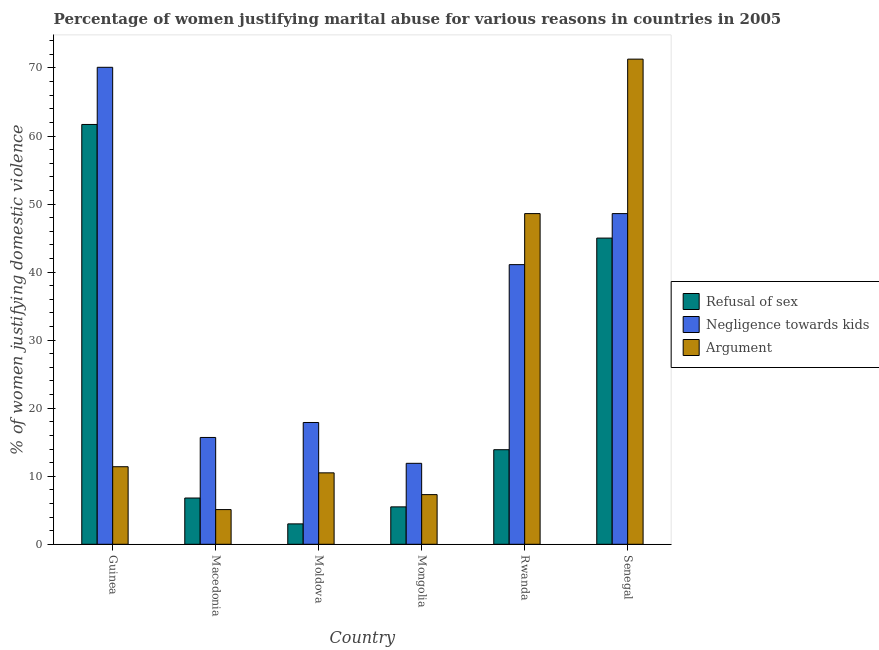How many groups of bars are there?
Provide a succinct answer. 6. Are the number of bars on each tick of the X-axis equal?
Offer a very short reply. Yes. How many bars are there on the 1st tick from the left?
Your answer should be compact. 3. How many bars are there on the 5th tick from the right?
Provide a short and direct response. 3. What is the label of the 1st group of bars from the left?
Provide a short and direct response. Guinea. Across all countries, what is the maximum percentage of women justifying domestic violence due to refusal of sex?
Ensure brevity in your answer.  61.7. Across all countries, what is the minimum percentage of women justifying domestic violence due to refusal of sex?
Your answer should be very brief. 3. In which country was the percentage of women justifying domestic violence due to negligence towards kids maximum?
Offer a very short reply. Guinea. In which country was the percentage of women justifying domestic violence due to arguments minimum?
Your answer should be compact. Macedonia. What is the total percentage of women justifying domestic violence due to negligence towards kids in the graph?
Provide a succinct answer. 205.3. What is the difference between the percentage of women justifying domestic violence due to negligence towards kids in Senegal and the percentage of women justifying domestic violence due to refusal of sex in Macedonia?
Make the answer very short. 41.8. What is the average percentage of women justifying domestic violence due to arguments per country?
Keep it short and to the point. 25.7. What is the difference between the percentage of women justifying domestic violence due to refusal of sex and percentage of women justifying domestic violence due to arguments in Macedonia?
Provide a succinct answer. 1.7. In how many countries, is the percentage of women justifying domestic violence due to refusal of sex greater than 30 %?
Give a very brief answer. 2. What is the ratio of the percentage of women justifying domestic violence due to refusal of sex in Macedonia to that in Mongolia?
Your answer should be very brief. 1.24. What is the difference between the highest and the second highest percentage of women justifying domestic violence due to negligence towards kids?
Offer a very short reply. 21.5. What is the difference between the highest and the lowest percentage of women justifying domestic violence due to negligence towards kids?
Provide a succinct answer. 58.2. What does the 1st bar from the left in Mongolia represents?
Keep it short and to the point. Refusal of sex. What does the 3rd bar from the right in Moldova represents?
Give a very brief answer. Refusal of sex. How many countries are there in the graph?
Your response must be concise. 6. What is the difference between two consecutive major ticks on the Y-axis?
Provide a succinct answer. 10. Does the graph contain any zero values?
Offer a terse response. No. Does the graph contain grids?
Provide a short and direct response. No. Where does the legend appear in the graph?
Your answer should be very brief. Center right. How are the legend labels stacked?
Keep it short and to the point. Vertical. What is the title of the graph?
Keep it short and to the point. Percentage of women justifying marital abuse for various reasons in countries in 2005. Does "Natural gas sources" appear as one of the legend labels in the graph?
Keep it short and to the point. No. What is the label or title of the X-axis?
Keep it short and to the point. Country. What is the label or title of the Y-axis?
Your answer should be compact. % of women justifying domestic violence. What is the % of women justifying domestic violence in Refusal of sex in Guinea?
Provide a succinct answer. 61.7. What is the % of women justifying domestic violence of Negligence towards kids in Guinea?
Your response must be concise. 70.1. What is the % of women justifying domestic violence of Refusal of sex in Macedonia?
Give a very brief answer. 6.8. What is the % of women justifying domestic violence of Negligence towards kids in Macedonia?
Keep it short and to the point. 15.7. What is the % of women justifying domestic violence in Refusal of sex in Moldova?
Offer a very short reply. 3. What is the % of women justifying domestic violence of Negligence towards kids in Moldova?
Your answer should be very brief. 17.9. What is the % of women justifying domestic violence of Argument in Moldova?
Offer a terse response. 10.5. What is the % of women justifying domestic violence in Negligence towards kids in Mongolia?
Your response must be concise. 11.9. What is the % of women justifying domestic violence in Negligence towards kids in Rwanda?
Offer a very short reply. 41.1. What is the % of women justifying domestic violence in Argument in Rwanda?
Provide a succinct answer. 48.6. What is the % of women justifying domestic violence in Negligence towards kids in Senegal?
Ensure brevity in your answer.  48.6. What is the % of women justifying domestic violence in Argument in Senegal?
Provide a succinct answer. 71.3. Across all countries, what is the maximum % of women justifying domestic violence of Refusal of sex?
Give a very brief answer. 61.7. Across all countries, what is the maximum % of women justifying domestic violence of Negligence towards kids?
Provide a succinct answer. 70.1. Across all countries, what is the maximum % of women justifying domestic violence in Argument?
Give a very brief answer. 71.3. Across all countries, what is the minimum % of women justifying domestic violence of Refusal of sex?
Offer a very short reply. 3. Across all countries, what is the minimum % of women justifying domestic violence in Negligence towards kids?
Your response must be concise. 11.9. What is the total % of women justifying domestic violence of Refusal of sex in the graph?
Give a very brief answer. 135.9. What is the total % of women justifying domestic violence of Negligence towards kids in the graph?
Your answer should be very brief. 205.3. What is the total % of women justifying domestic violence in Argument in the graph?
Your answer should be compact. 154.2. What is the difference between the % of women justifying domestic violence in Refusal of sex in Guinea and that in Macedonia?
Provide a succinct answer. 54.9. What is the difference between the % of women justifying domestic violence of Negligence towards kids in Guinea and that in Macedonia?
Keep it short and to the point. 54.4. What is the difference between the % of women justifying domestic violence in Argument in Guinea and that in Macedonia?
Offer a very short reply. 6.3. What is the difference between the % of women justifying domestic violence of Refusal of sex in Guinea and that in Moldova?
Provide a short and direct response. 58.7. What is the difference between the % of women justifying domestic violence of Negligence towards kids in Guinea and that in Moldova?
Offer a terse response. 52.2. What is the difference between the % of women justifying domestic violence of Refusal of sex in Guinea and that in Mongolia?
Ensure brevity in your answer.  56.2. What is the difference between the % of women justifying domestic violence in Negligence towards kids in Guinea and that in Mongolia?
Ensure brevity in your answer.  58.2. What is the difference between the % of women justifying domestic violence in Argument in Guinea and that in Mongolia?
Provide a succinct answer. 4.1. What is the difference between the % of women justifying domestic violence in Refusal of sex in Guinea and that in Rwanda?
Keep it short and to the point. 47.8. What is the difference between the % of women justifying domestic violence in Argument in Guinea and that in Rwanda?
Provide a succinct answer. -37.2. What is the difference between the % of women justifying domestic violence in Negligence towards kids in Guinea and that in Senegal?
Your response must be concise. 21.5. What is the difference between the % of women justifying domestic violence of Argument in Guinea and that in Senegal?
Ensure brevity in your answer.  -59.9. What is the difference between the % of women justifying domestic violence of Refusal of sex in Macedonia and that in Moldova?
Provide a short and direct response. 3.8. What is the difference between the % of women justifying domestic violence of Argument in Macedonia and that in Moldova?
Offer a terse response. -5.4. What is the difference between the % of women justifying domestic violence of Argument in Macedonia and that in Mongolia?
Ensure brevity in your answer.  -2.2. What is the difference between the % of women justifying domestic violence in Refusal of sex in Macedonia and that in Rwanda?
Provide a succinct answer. -7.1. What is the difference between the % of women justifying domestic violence of Negligence towards kids in Macedonia and that in Rwanda?
Make the answer very short. -25.4. What is the difference between the % of women justifying domestic violence of Argument in Macedonia and that in Rwanda?
Provide a succinct answer. -43.5. What is the difference between the % of women justifying domestic violence in Refusal of sex in Macedonia and that in Senegal?
Your answer should be compact. -38.2. What is the difference between the % of women justifying domestic violence of Negligence towards kids in Macedonia and that in Senegal?
Your answer should be compact. -32.9. What is the difference between the % of women justifying domestic violence of Argument in Macedonia and that in Senegal?
Give a very brief answer. -66.2. What is the difference between the % of women justifying domestic violence in Refusal of sex in Moldova and that in Mongolia?
Keep it short and to the point. -2.5. What is the difference between the % of women justifying domestic violence of Argument in Moldova and that in Mongolia?
Give a very brief answer. 3.2. What is the difference between the % of women justifying domestic violence in Refusal of sex in Moldova and that in Rwanda?
Provide a short and direct response. -10.9. What is the difference between the % of women justifying domestic violence in Negligence towards kids in Moldova and that in Rwanda?
Your response must be concise. -23.2. What is the difference between the % of women justifying domestic violence of Argument in Moldova and that in Rwanda?
Your answer should be very brief. -38.1. What is the difference between the % of women justifying domestic violence in Refusal of sex in Moldova and that in Senegal?
Offer a very short reply. -42. What is the difference between the % of women justifying domestic violence in Negligence towards kids in Moldova and that in Senegal?
Offer a very short reply. -30.7. What is the difference between the % of women justifying domestic violence of Argument in Moldova and that in Senegal?
Give a very brief answer. -60.8. What is the difference between the % of women justifying domestic violence in Negligence towards kids in Mongolia and that in Rwanda?
Give a very brief answer. -29.2. What is the difference between the % of women justifying domestic violence in Argument in Mongolia and that in Rwanda?
Offer a terse response. -41.3. What is the difference between the % of women justifying domestic violence in Refusal of sex in Mongolia and that in Senegal?
Offer a terse response. -39.5. What is the difference between the % of women justifying domestic violence in Negligence towards kids in Mongolia and that in Senegal?
Give a very brief answer. -36.7. What is the difference between the % of women justifying domestic violence in Argument in Mongolia and that in Senegal?
Provide a succinct answer. -64. What is the difference between the % of women justifying domestic violence in Refusal of sex in Rwanda and that in Senegal?
Your response must be concise. -31.1. What is the difference between the % of women justifying domestic violence of Negligence towards kids in Rwanda and that in Senegal?
Provide a short and direct response. -7.5. What is the difference between the % of women justifying domestic violence of Argument in Rwanda and that in Senegal?
Make the answer very short. -22.7. What is the difference between the % of women justifying domestic violence in Refusal of sex in Guinea and the % of women justifying domestic violence in Argument in Macedonia?
Offer a very short reply. 56.6. What is the difference between the % of women justifying domestic violence in Refusal of sex in Guinea and the % of women justifying domestic violence in Negligence towards kids in Moldova?
Provide a short and direct response. 43.8. What is the difference between the % of women justifying domestic violence in Refusal of sex in Guinea and the % of women justifying domestic violence in Argument in Moldova?
Ensure brevity in your answer.  51.2. What is the difference between the % of women justifying domestic violence in Negligence towards kids in Guinea and the % of women justifying domestic violence in Argument in Moldova?
Give a very brief answer. 59.6. What is the difference between the % of women justifying domestic violence in Refusal of sex in Guinea and the % of women justifying domestic violence in Negligence towards kids in Mongolia?
Give a very brief answer. 49.8. What is the difference between the % of women justifying domestic violence of Refusal of sex in Guinea and the % of women justifying domestic violence of Argument in Mongolia?
Provide a succinct answer. 54.4. What is the difference between the % of women justifying domestic violence in Negligence towards kids in Guinea and the % of women justifying domestic violence in Argument in Mongolia?
Your answer should be very brief. 62.8. What is the difference between the % of women justifying domestic violence of Refusal of sex in Guinea and the % of women justifying domestic violence of Negligence towards kids in Rwanda?
Your answer should be compact. 20.6. What is the difference between the % of women justifying domestic violence of Refusal of sex in Guinea and the % of women justifying domestic violence of Argument in Rwanda?
Provide a succinct answer. 13.1. What is the difference between the % of women justifying domestic violence of Refusal of sex in Macedonia and the % of women justifying domestic violence of Negligence towards kids in Moldova?
Keep it short and to the point. -11.1. What is the difference between the % of women justifying domestic violence of Refusal of sex in Macedonia and the % of women justifying domestic violence of Argument in Moldova?
Give a very brief answer. -3.7. What is the difference between the % of women justifying domestic violence of Negligence towards kids in Macedonia and the % of women justifying domestic violence of Argument in Moldova?
Ensure brevity in your answer.  5.2. What is the difference between the % of women justifying domestic violence of Refusal of sex in Macedonia and the % of women justifying domestic violence of Negligence towards kids in Mongolia?
Give a very brief answer. -5.1. What is the difference between the % of women justifying domestic violence of Refusal of sex in Macedonia and the % of women justifying domestic violence of Argument in Mongolia?
Ensure brevity in your answer.  -0.5. What is the difference between the % of women justifying domestic violence of Negligence towards kids in Macedonia and the % of women justifying domestic violence of Argument in Mongolia?
Provide a succinct answer. 8.4. What is the difference between the % of women justifying domestic violence in Refusal of sex in Macedonia and the % of women justifying domestic violence in Negligence towards kids in Rwanda?
Provide a short and direct response. -34.3. What is the difference between the % of women justifying domestic violence of Refusal of sex in Macedonia and the % of women justifying domestic violence of Argument in Rwanda?
Your response must be concise. -41.8. What is the difference between the % of women justifying domestic violence of Negligence towards kids in Macedonia and the % of women justifying domestic violence of Argument in Rwanda?
Make the answer very short. -32.9. What is the difference between the % of women justifying domestic violence of Refusal of sex in Macedonia and the % of women justifying domestic violence of Negligence towards kids in Senegal?
Offer a terse response. -41.8. What is the difference between the % of women justifying domestic violence in Refusal of sex in Macedonia and the % of women justifying domestic violence in Argument in Senegal?
Your response must be concise. -64.5. What is the difference between the % of women justifying domestic violence in Negligence towards kids in Macedonia and the % of women justifying domestic violence in Argument in Senegal?
Provide a short and direct response. -55.6. What is the difference between the % of women justifying domestic violence of Negligence towards kids in Moldova and the % of women justifying domestic violence of Argument in Mongolia?
Give a very brief answer. 10.6. What is the difference between the % of women justifying domestic violence of Refusal of sex in Moldova and the % of women justifying domestic violence of Negligence towards kids in Rwanda?
Keep it short and to the point. -38.1. What is the difference between the % of women justifying domestic violence of Refusal of sex in Moldova and the % of women justifying domestic violence of Argument in Rwanda?
Provide a succinct answer. -45.6. What is the difference between the % of women justifying domestic violence of Negligence towards kids in Moldova and the % of women justifying domestic violence of Argument in Rwanda?
Make the answer very short. -30.7. What is the difference between the % of women justifying domestic violence in Refusal of sex in Moldova and the % of women justifying domestic violence in Negligence towards kids in Senegal?
Give a very brief answer. -45.6. What is the difference between the % of women justifying domestic violence of Refusal of sex in Moldova and the % of women justifying domestic violence of Argument in Senegal?
Make the answer very short. -68.3. What is the difference between the % of women justifying domestic violence in Negligence towards kids in Moldova and the % of women justifying domestic violence in Argument in Senegal?
Your answer should be very brief. -53.4. What is the difference between the % of women justifying domestic violence in Refusal of sex in Mongolia and the % of women justifying domestic violence in Negligence towards kids in Rwanda?
Make the answer very short. -35.6. What is the difference between the % of women justifying domestic violence of Refusal of sex in Mongolia and the % of women justifying domestic violence of Argument in Rwanda?
Your answer should be very brief. -43.1. What is the difference between the % of women justifying domestic violence of Negligence towards kids in Mongolia and the % of women justifying domestic violence of Argument in Rwanda?
Your response must be concise. -36.7. What is the difference between the % of women justifying domestic violence of Refusal of sex in Mongolia and the % of women justifying domestic violence of Negligence towards kids in Senegal?
Your response must be concise. -43.1. What is the difference between the % of women justifying domestic violence of Refusal of sex in Mongolia and the % of women justifying domestic violence of Argument in Senegal?
Give a very brief answer. -65.8. What is the difference between the % of women justifying domestic violence in Negligence towards kids in Mongolia and the % of women justifying domestic violence in Argument in Senegal?
Make the answer very short. -59.4. What is the difference between the % of women justifying domestic violence of Refusal of sex in Rwanda and the % of women justifying domestic violence of Negligence towards kids in Senegal?
Provide a succinct answer. -34.7. What is the difference between the % of women justifying domestic violence of Refusal of sex in Rwanda and the % of women justifying domestic violence of Argument in Senegal?
Your response must be concise. -57.4. What is the difference between the % of women justifying domestic violence of Negligence towards kids in Rwanda and the % of women justifying domestic violence of Argument in Senegal?
Give a very brief answer. -30.2. What is the average % of women justifying domestic violence of Refusal of sex per country?
Give a very brief answer. 22.65. What is the average % of women justifying domestic violence in Negligence towards kids per country?
Your answer should be compact. 34.22. What is the average % of women justifying domestic violence of Argument per country?
Provide a succinct answer. 25.7. What is the difference between the % of women justifying domestic violence in Refusal of sex and % of women justifying domestic violence in Argument in Guinea?
Give a very brief answer. 50.3. What is the difference between the % of women justifying domestic violence of Negligence towards kids and % of women justifying domestic violence of Argument in Guinea?
Your answer should be very brief. 58.7. What is the difference between the % of women justifying domestic violence of Refusal of sex and % of women justifying domestic violence of Negligence towards kids in Macedonia?
Your response must be concise. -8.9. What is the difference between the % of women justifying domestic violence of Refusal of sex and % of women justifying domestic violence of Argument in Macedonia?
Keep it short and to the point. 1.7. What is the difference between the % of women justifying domestic violence of Refusal of sex and % of women justifying domestic violence of Negligence towards kids in Moldova?
Your answer should be very brief. -14.9. What is the difference between the % of women justifying domestic violence of Negligence towards kids and % of women justifying domestic violence of Argument in Moldova?
Provide a succinct answer. 7.4. What is the difference between the % of women justifying domestic violence of Refusal of sex and % of women justifying domestic violence of Negligence towards kids in Mongolia?
Provide a succinct answer. -6.4. What is the difference between the % of women justifying domestic violence in Refusal of sex and % of women justifying domestic violence in Negligence towards kids in Rwanda?
Your answer should be compact. -27.2. What is the difference between the % of women justifying domestic violence in Refusal of sex and % of women justifying domestic violence in Argument in Rwanda?
Provide a short and direct response. -34.7. What is the difference between the % of women justifying domestic violence in Refusal of sex and % of women justifying domestic violence in Negligence towards kids in Senegal?
Your response must be concise. -3.6. What is the difference between the % of women justifying domestic violence of Refusal of sex and % of women justifying domestic violence of Argument in Senegal?
Keep it short and to the point. -26.3. What is the difference between the % of women justifying domestic violence in Negligence towards kids and % of women justifying domestic violence in Argument in Senegal?
Offer a terse response. -22.7. What is the ratio of the % of women justifying domestic violence of Refusal of sex in Guinea to that in Macedonia?
Give a very brief answer. 9.07. What is the ratio of the % of women justifying domestic violence of Negligence towards kids in Guinea to that in Macedonia?
Your response must be concise. 4.46. What is the ratio of the % of women justifying domestic violence of Argument in Guinea to that in Macedonia?
Provide a short and direct response. 2.24. What is the ratio of the % of women justifying domestic violence of Refusal of sex in Guinea to that in Moldova?
Give a very brief answer. 20.57. What is the ratio of the % of women justifying domestic violence in Negligence towards kids in Guinea to that in Moldova?
Your answer should be very brief. 3.92. What is the ratio of the % of women justifying domestic violence of Argument in Guinea to that in Moldova?
Offer a terse response. 1.09. What is the ratio of the % of women justifying domestic violence of Refusal of sex in Guinea to that in Mongolia?
Provide a short and direct response. 11.22. What is the ratio of the % of women justifying domestic violence of Negligence towards kids in Guinea to that in Mongolia?
Give a very brief answer. 5.89. What is the ratio of the % of women justifying domestic violence in Argument in Guinea to that in Mongolia?
Ensure brevity in your answer.  1.56. What is the ratio of the % of women justifying domestic violence of Refusal of sex in Guinea to that in Rwanda?
Offer a terse response. 4.44. What is the ratio of the % of women justifying domestic violence in Negligence towards kids in Guinea to that in Rwanda?
Make the answer very short. 1.71. What is the ratio of the % of women justifying domestic violence of Argument in Guinea to that in Rwanda?
Keep it short and to the point. 0.23. What is the ratio of the % of women justifying domestic violence of Refusal of sex in Guinea to that in Senegal?
Make the answer very short. 1.37. What is the ratio of the % of women justifying domestic violence of Negligence towards kids in Guinea to that in Senegal?
Your answer should be compact. 1.44. What is the ratio of the % of women justifying domestic violence of Argument in Guinea to that in Senegal?
Your response must be concise. 0.16. What is the ratio of the % of women justifying domestic violence of Refusal of sex in Macedonia to that in Moldova?
Your response must be concise. 2.27. What is the ratio of the % of women justifying domestic violence of Negligence towards kids in Macedonia to that in Moldova?
Provide a succinct answer. 0.88. What is the ratio of the % of women justifying domestic violence in Argument in Macedonia to that in Moldova?
Your answer should be compact. 0.49. What is the ratio of the % of women justifying domestic violence of Refusal of sex in Macedonia to that in Mongolia?
Keep it short and to the point. 1.24. What is the ratio of the % of women justifying domestic violence in Negligence towards kids in Macedonia to that in Mongolia?
Ensure brevity in your answer.  1.32. What is the ratio of the % of women justifying domestic violence in Argument in Macedonia to that in Mongolia?
Give a very brief answer. 0.7. What is the ratio of the % of women justifying domestic violence of Refusal of sex in Macedonia to that in Rwanda?
Provide a succinct answer. 0.49. What is the ratio of the % of women justifying domestic violence in Negligence towards kids in Macedonia to that in Rwanda?
Offer a very short reply. 0.38. What is the ratio of the % of women justifying domestic violence in Argument in Macedonia to that in Rwanda?
Your response must be concise. 0.1. What is the ratio of the % of women justifying domestic violence in Refusal of sex in Macedonia to that in Senegal?
Make the answer very short. 0.15. What is the ratio of the % of women justifying domestic violence of Negligence towards kids in Macedonia to that in Senegal?
Provide a succinct answer. 0.32. What is the ratio of the % of women justifying domestic violence in Argument in Macedonia to that in Senegal?
Ensure brevity in your answer.  0.07. What is the ratio of the % of women justifying domestic violence in Refusal of sex in Moldova to that in Mongolia?
Provide a succinct answer. 0.55. What is the ratio of the % of women justifying domestic violence in Negligence towards kids in Moldova to that in Mongolia?
Provide a short and direct response. 1.5. What is the ratio of the % of women justifying domestic violence of Argument in Moldova to that in Mongolia?
Provide a short and direct response. 1.44. What is the ratio of the % of women justifying domestic violence of Refusal of sex in Moldova to that in Rwanda?
Make the answer very short. 0.22. What is the ratio of the % of women justifying domestic violence of Negligence towards kids in Moldova to that in Rwanda?
Keep it short and to the point. 0.44. What is the ratio of the % of women justifying domestic violence in Argument in Moldova to that in Rwanda?
Offer a very short reply. 0.22. What is the ratio of the % of women justifying domestic violence in Refusal of sex in Moldova to that in Senegal?
Make the answer very short. 0.07. What is the ratio of the % of women justifying domestic violence of Negligence towards kids in Moldova to that in Senegal?
Provide a short and direct response. 0.37. What is the ratio of the % of women justifying domestic violence of Argument in Moldova to that in Senegal?
Offer a very short reply. 0.15. What is the ratio of the % of women justifying domestic violence of Refusal of sex in Mongolia to that in Rwanda?
Your answer should be very brief. 0.4. What is the ratio of the % of women justifying domestic violence in Negligence towards kids in Mongolia to that in Rwanda?
Provide a succinct answer. 0.29. What is the ratio of the % of women justifying domestic violence in Argument in Mongolia to that in Rwanda?
Offer a very short reply. 0.15. What is the ratio of the % of women justifying domestic violence in Refusal of sex in Mongolia to that in Senegal?
Provide a short and direct response. 0.12. What is the ratio of the % of women justifying domestic violence of Negligence towards kids in Mongolia to that in Senegal?
Your response must be concise. 0.24. What is the ratio of the % of women justifying domestic violence in Argument in Mongolia to that in Senegal?
Offer a very short reply. 0.1. What is the ratio of the % of women justifying domestic violence in Refusal of sex in Rwanda to that in Senegal?
Ensure brevity in your answer.  0.31. What is the ratio of the % of women justifying domestic violence in Negligence towards kids in Rwanda to that in Senegal?
Your response must be concise. 0.85. What is the ratio of the % of women justifying domestic violence of Argument in Rwanda to that in Senegal?
Your answer should be compact. 0.68. What is the difference between the highest and the second highest % of women justifying domestic violence of Negligence towards kids?
Make the answer very short. 21.5. What is the difference between the highest and the second highest % of women justifying domestic violence in Argument?
Ensure brevity in your answer.  22.7. What is the difference between the highest and the lowest % of women justifying domestic violence of Refusal of sex?
Your response must be concise. 58.7. What is the difference between the highest and the lowest % of women justifying domestic violence of Negligence towards kids?
Your answer should be very brief. 58.2. What is the difference between the highest and the lowest % of women justifying domestic violence in Argument?
Provide a succinct answer. 66.2. 